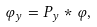<formula> <loc_0><loc_0><loc_500><loc_500>\varphi _ { y } = P _ { y } * \varphi ,</formula> 